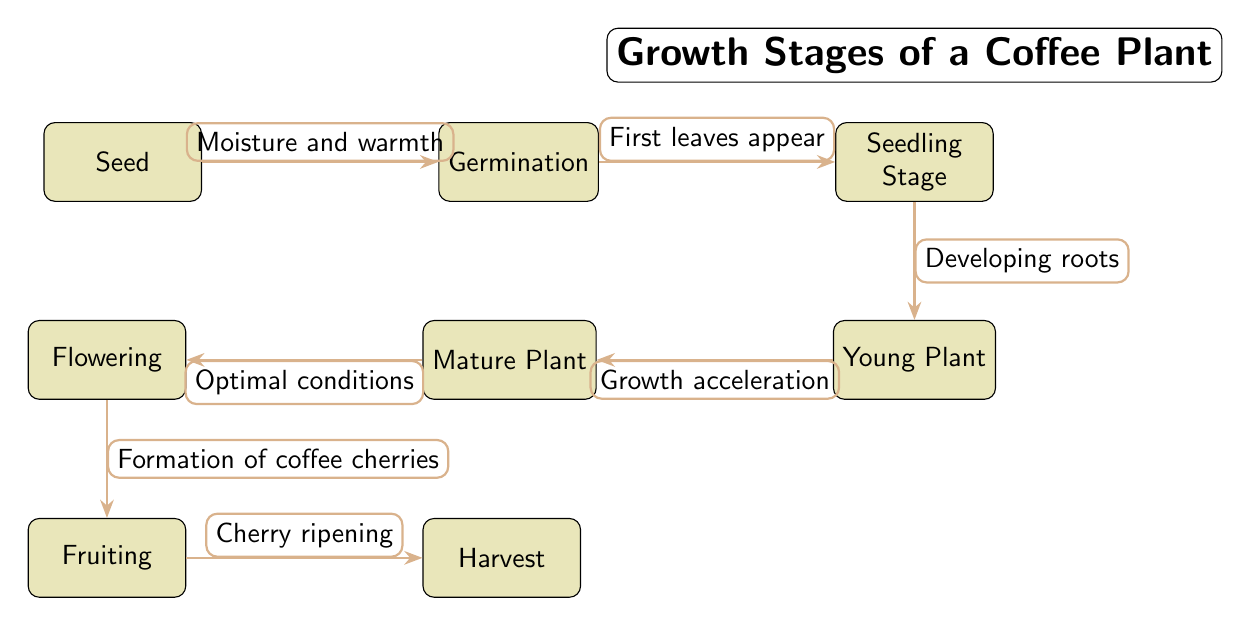What is the first stage of the coffee plant's growth? The diagram shows the first node labeled "Seed," indicating that it is the initial growth stage of the coffee plant.
Answer: Seed How many stages are shown in the diagram? By counting all the labeled nodes in the diagram, we see there are a total of 7 stages: Seed, Germination, Seedling Stage, Young Plant, Mature Plant, Flowering, Fruiting, and Harvest.
Answer: 7 What condition is required for germination? The arrow from "Seed" to "Germination" states "Moisture and warmth" as the necessary condition for the first stage to transition.
Answer: Moisture and warmth What comes after the young plant stage? The diagram indicates a transition from "Young Plant" to "Mature Plant," where the young plant develops into a mature one.
Answer: Mature Plant Which stage involves the formation of coffee cherries? According to the diagram, the transition from "Flowering" leads to "Fruiting," which is when the coffee cherries form.
Answer: Fruiting What is the last stage before harvest? Following the flow in the diagram, the stage labeled "Fruiting" directly precedes "Harvest," indicating it is the final growth stage before harvesting occurs.
Answer: Fruiting What transition occurs during the seedling stage? The arrow from "Seedling Stage" to "Young Plant" is labeled "Developing roots," which describes the key transition for the seedling stage.
Answer: Developing roots How does a mature plant begin to flower? The diagram shows the transition from "Mature Plant" to "Flowering," which is triggered under "Optimal conditions," connecting these two stages through specific environmental factors.
Answer: Optimal conditions 